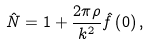Convert formula to latex. <formula><loc_0><loc_0><loc_500><loc_500>\hat { N } = 1 + \frac { 2 \pi \rho } { { k ^ { 2 } } } \hat { f } \left ( { 0 } \right ) ,</formula> 